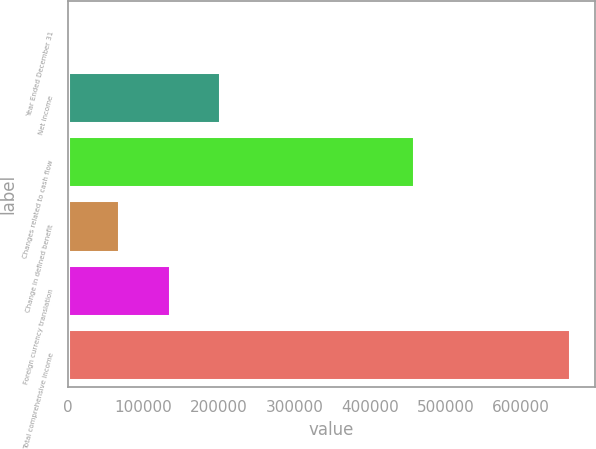Convert chart to OTSL. <chart><loc_0><loc_0><loc_500><loc_500><bar_chart><fcel>Year Ended December 31<fcel>Net income<fcel>Changes related to cash flow<fcel>Change in defined benefit<fcel>Foreign currency translation<fcel>Total comprehensive income<nl><fcel>2009<fcel>200933<fcel>458220<fcel>68317.1<fcel>134625<fcel>665090<nl></chart> 